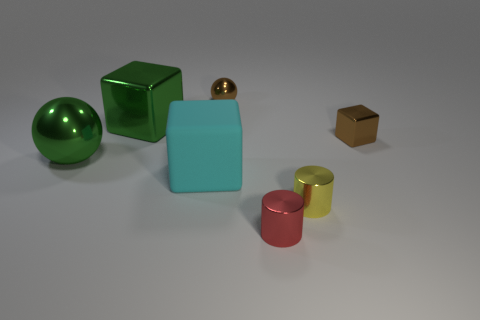Is the rubber thing the same shape as the small yellow metallic object?
Give a very brief answer. No. There is a cylinder that is the same size as the red object; what color is it?
Your answer should be very brief. Yellow. What is the size of the green metallic object that is the same shape as the cyan matte thing?
Ensure brevity in your answer.  Large. What shape is the small red metallic object right of the cyan cube?
Your answer should be compact. Cylinder. There is a red metal thing; is it the same shape as the yellow shiny thing that is left of the brown block?
Keep it short and to the point. Yes. Are there an equal number of tiny yellow cylinders that are behind the small yellow thing and yellow things left of the red cylinder?
Offer a terse response. Yes. The large object that is the same color as the large shiny block is what shape?
Your response must be concise. Sphere. Does the metallic cylinder right of the red cylinder have the same color as the metallic ball left of the tiny sphere?
Your answer should be compact. No. Is the number of big things that are behind the brown shiny block greater than the number of red shiny things?
Your answer should be compact. No. What material is the cyan object?
Provide a short and direct response. Rubber. 